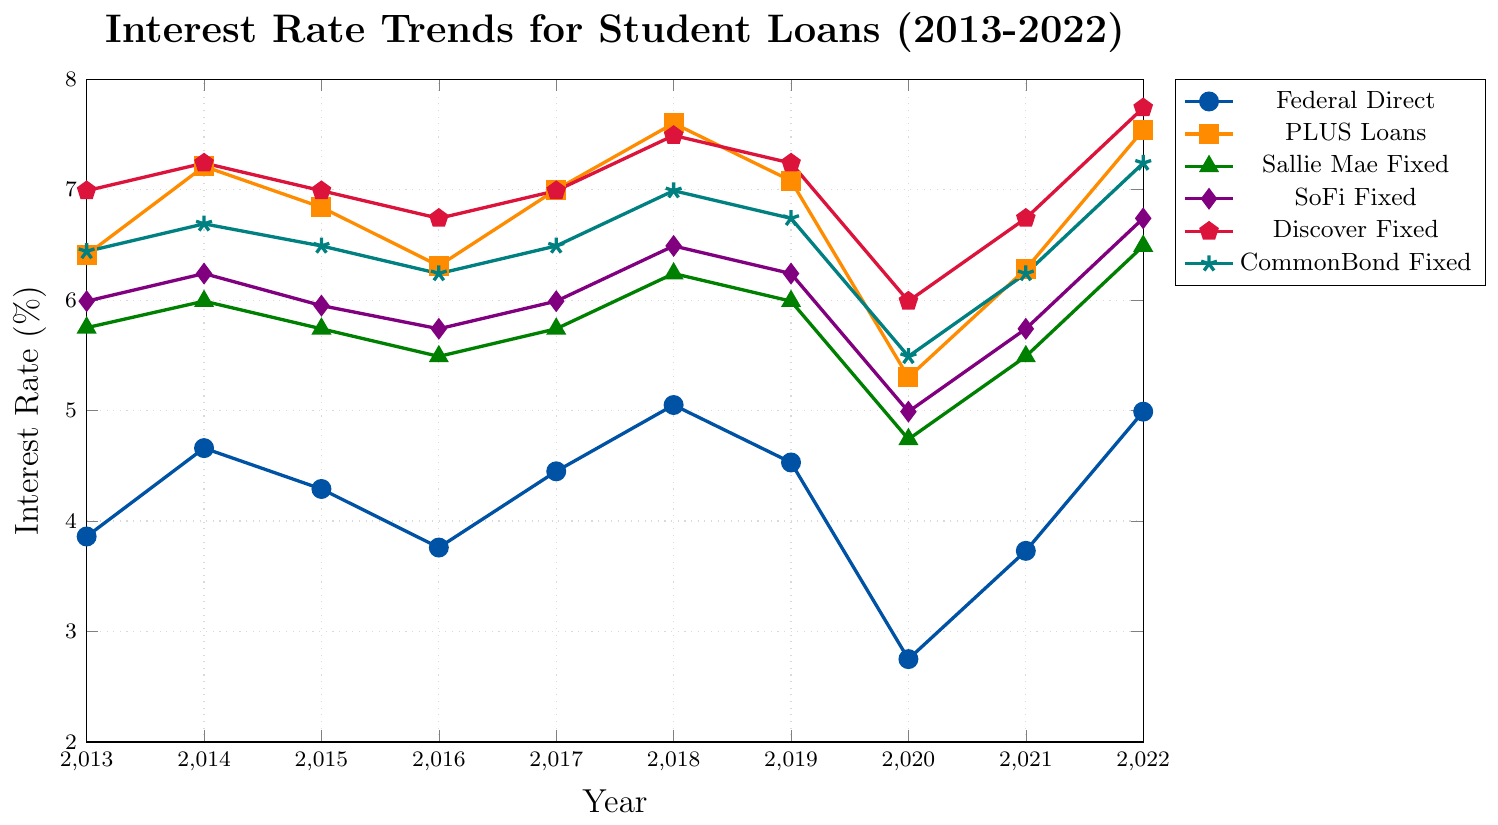What's the interest rate trend for Federal Direct loans from 2013 to 2022? Observe the blue line representing Federal Direct loans in the chart. The rates start at 3.86% in 2013, fluctuate between 2.75% and 5.05% over the years, and end at 4.99% in 2022.
Answer: The rates fluctuate and end higher at 4.99% in 2022 Which loan type had the highest interest rate in 2020? Look at the 2020 data points for all loan types. Discover Fixed loans have the highest interest rate at 5.99%.
Answer: Discover Fixed loans In what year did PLUS loans have the lowest interest rate and what was the rate? Check the orange line representing PLUS loans. The lowest rate occurs in 2020 with a rate of 5.30%.
Answer: 2020, 5.30% Which two loan types had the closest interest rates in 2019? Compare the 2019 data points for all loan types. Federal Direct loans and Sallie Mae Fixed loans have the closest rates, both at approximately 4.53% and 5.99%, respectively, showing the smallest difference.
Answer: Federal Direct and Sallie Mae Fixed What is the average interest rate of CommonBond Fixed loans from 2013 to 2022? Sum the CommonBond Fixed interest rates over the years (6.44 + 6.69 + 6.49 + 6.24 + 6.49 + 6.99 + 6.74 + 5.49 + 6.24 + 7.24) and divide by the number of years (10). This equals (64.05/10).
Answer: 6.405% By how much did the interest rate for SoFi Fixed loans change from 2013 to 2020? Subtract the 2020 interest rate (4.99%) from the 2013 rate (5.99%). The change is 5.99% - 4.99%.
Answer: 1% Which loan type experienced the highest increase in interest rate from its lowest to its highest point between 2013 and 2022? Compare the difference between the highest and lowest points for all loan types: Federal Direct (5.05% - 2.75% = 2.30%), PLUS Loans (7.60% - 5.30% = 2.30%), Sallie Mae Fixed (6.49% - 4.74% = 1.75%), SoFi Fixed (6.74% - 4.99% = 1.75%), Discover Fixed (7.74% - 5.99% = 1.75%), CommonBond Fixed (7.24% - 5.49% = 1.75%). Both Federal Direct and PLUS Loans experienced a maximum change of 2.30%.
Answer: Federal Direct and PLUS Loans Compare the interest rates of Discover Fixed and CommonBond Fixed in 2018. Which one was higher and by how much? The 2018 interest rate for Discover Fixed is 7.49%, and for CommonBond Fixed it is 6.99%. The difference is 7.49% - 6.99%.
Answer: Discover Fixed by 0.50% What is the trend in interest rates for Sallie Mae Fixed loans from 2020 to 2022? Observe the green line for Sallie Mae Fixed loans. The rates increase from 4.74% in 2020 to 5.49% in 2021 and then to 6.49% in 2022.
Answer: Increasing trend Which year had the largest difference between Sallie Mae Fixed and SoFi Fixed loan interest rates? Calculate the yearly differences: 2013 (5.75 - 5.99 = -0.24), 2014 (5.99 - 6.24 = -0.25), 2015 (5.74 - 5.95 = -0.21), 2016 (5.49 - 5.74 = -0.25), 2017 (5.74 - 5.99 = -0.25), 2018 (6.24 - 6.49 = -0.25), 2019 (5.99 - 6.24 = -0.25), 2020 (4.74 - 4.99 = -0.25), 2021 (5.49 - 5.74 = -0.25), 2022 (6.49 - 6.74 = -0.25). The largest difference is in 2013.
Answer: 2013 